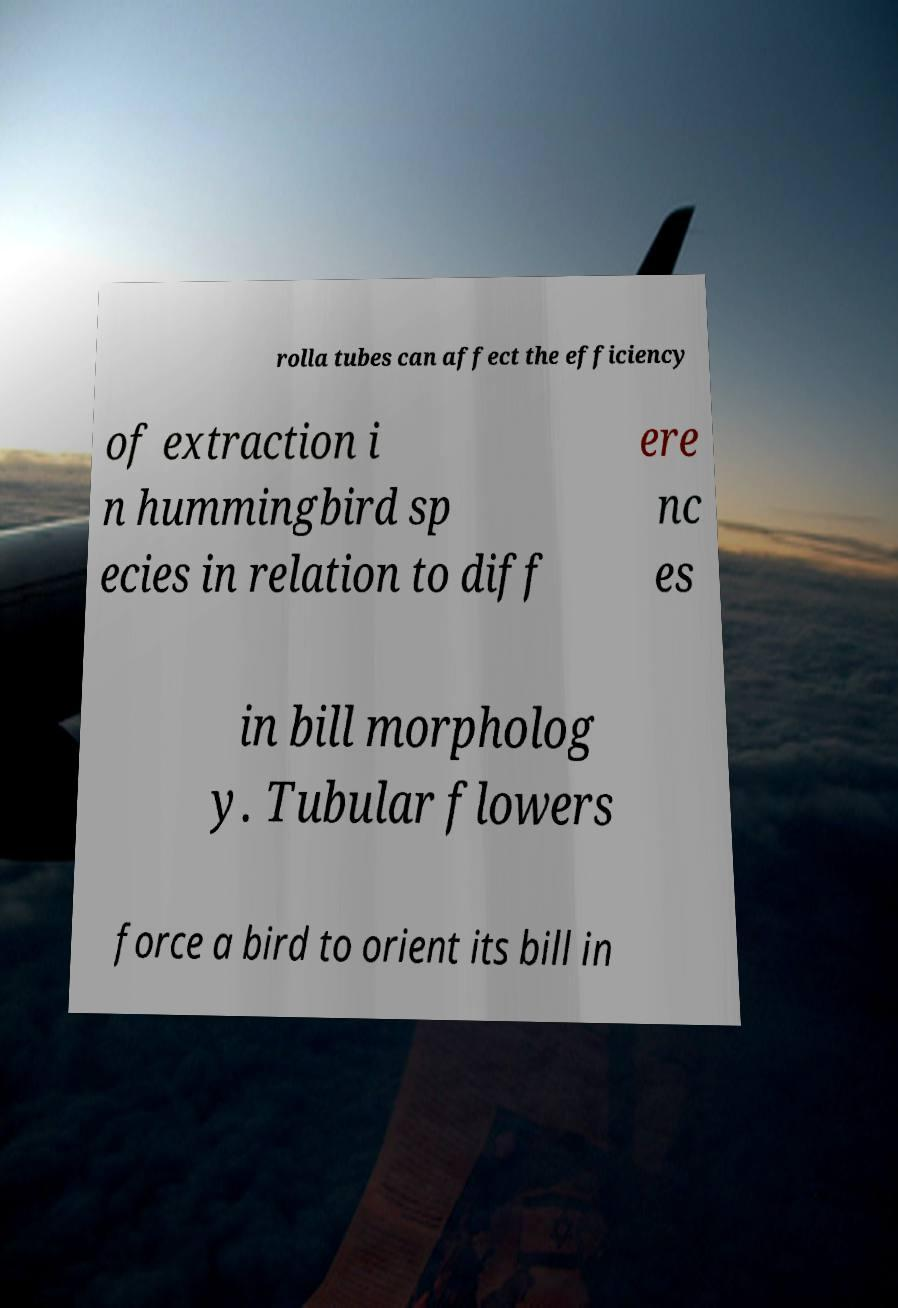Could you extract and type out the text from this image? rolla tubes can affect the efficiency of extraction i n hummingbird sp ecies in relation to diff ere nc es in bill morpholog y. Tubular flowers force a bird to orient its bill in 